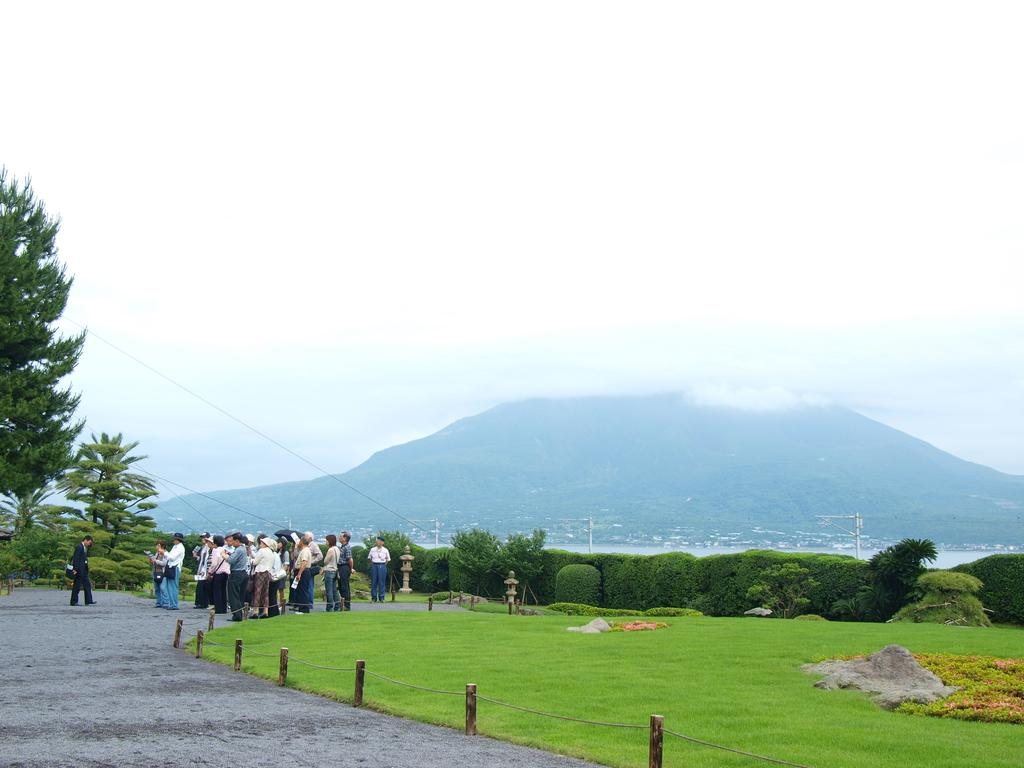What can be seen in the image? There are people standing in the image. What is the ground covered with? The ground is covered with grass. What can be seen in the background of the image? There are trees visible in the background. What other vegetation is present in the image? There are bushes in the image. Can you tell me how many rabbits are hopping around in the image? There are no rabbits present in the image. What type of hand is visible in the image? There is no hand visible in the image. 